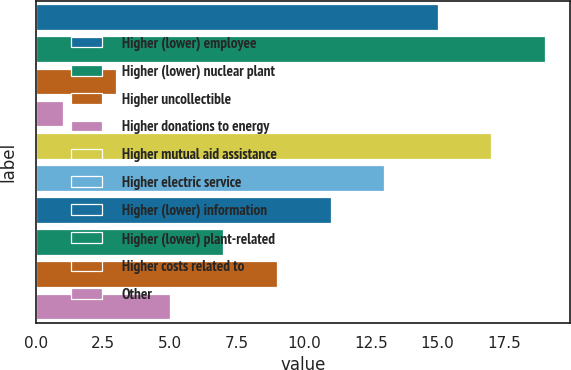Convert chart to OTSL. <chart><loc_0><loc_0><loc_500><loc_500><bar_chart><fcel>Higher (lower) employee<fcel>Higher (lower) nuclear plant<fcel>Higher uncollectible<fcel>Higher donations to energy<fcel>Higher mutual aid assistance<fcel>Higher electric service<fcel>Higher (lower) information<fcel>Higher (lower) plant-related<fcel>Higher costs related to<fcel>Other<nl><fcel>15<fcel>19<fcel>3<fcel>1<fcel>17<fcel>13<fcel>11<fcel>7<fcel>9<fcel>5<nl></chart> 